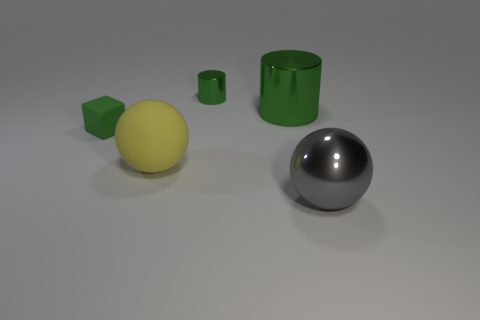What is the texture of the yellow thing in the image? The yellow object appears to have a smooth, matte texture, indicating it could be made out of a material like plastic or painted wood, without any shiny or reflective qualities. 